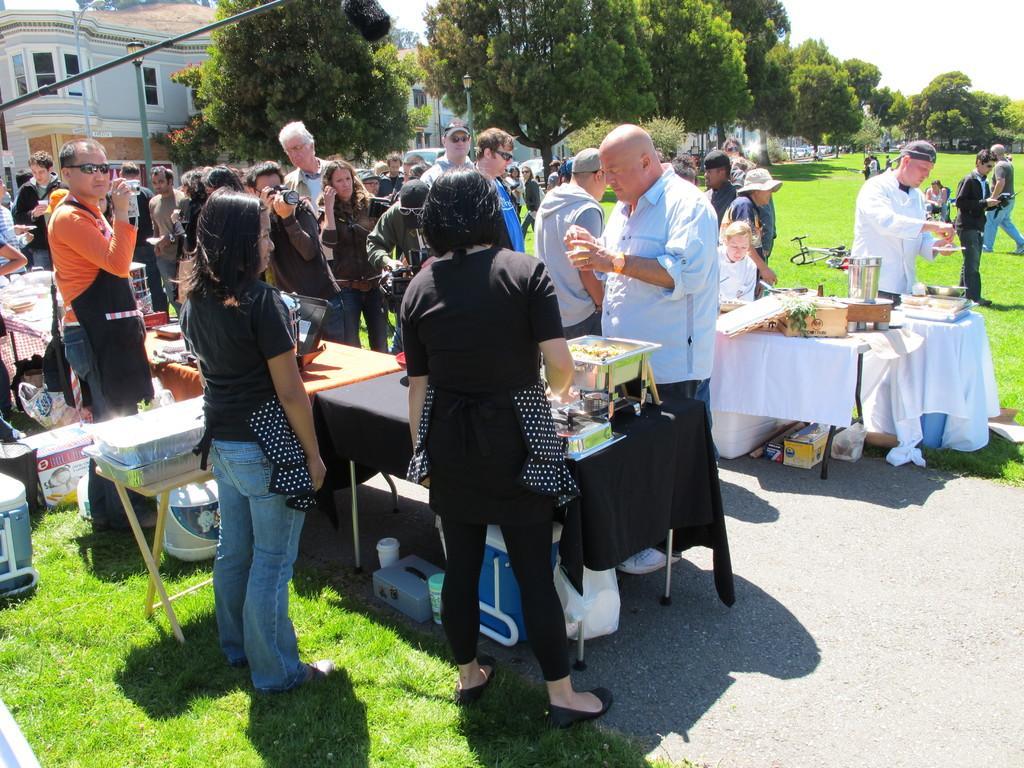Describe this image in one or two sentences. There are group of people standing and someone eating a food on table and behind them there are trees and building. 